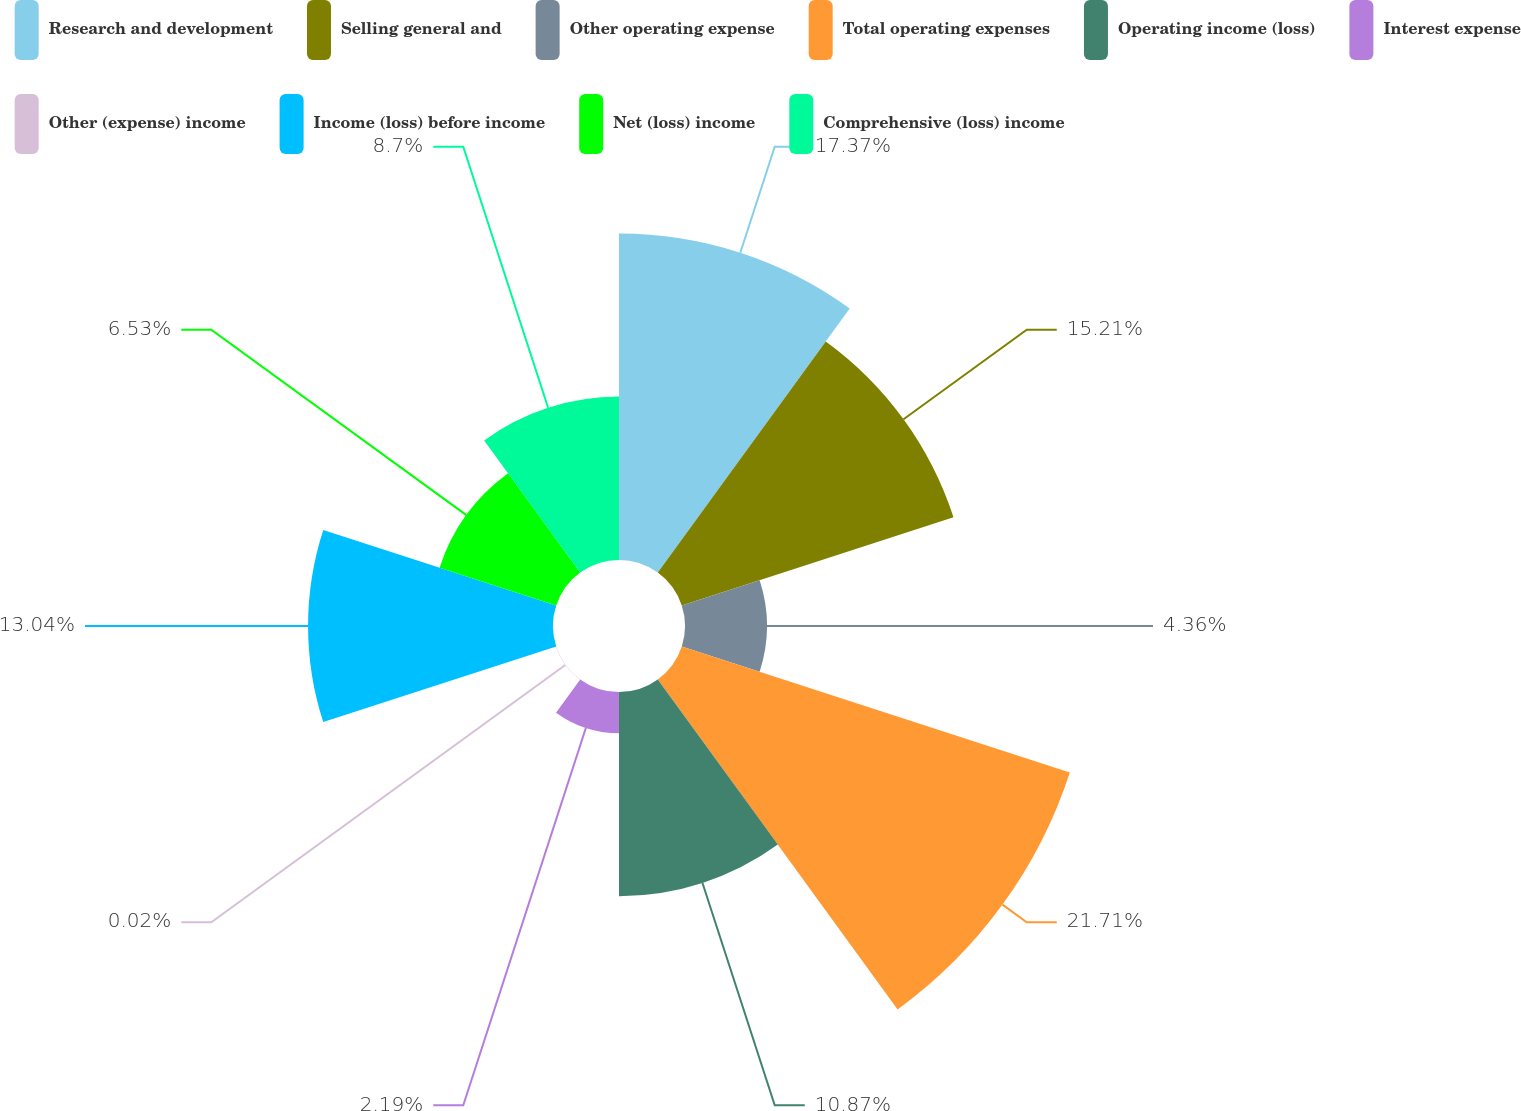Convert chart to OTSL. <chart><loc_0><loc_0><loc_500><loc_500><pie_chart><fcel>Research and development<fcel>Selling general and<fcel>Other operating expense<fcel>Total operating expenses<fcel>Operating income (loss)<fcel>Interest expense<fcel>Other (expense) income<fcel>Income (loss) before income<fcel>Net (loss) income<fcel>Comprehensive (loss) income<nl><fcel>17.38%<fcel>15.21%<fcel>4.36%<fcel>21.72%<fcel>10.87%<fcel>2.19%<fcel>0.02%<fcel>13.04%<fcel>6.53%<fcel>8.7%<nl></chart> 